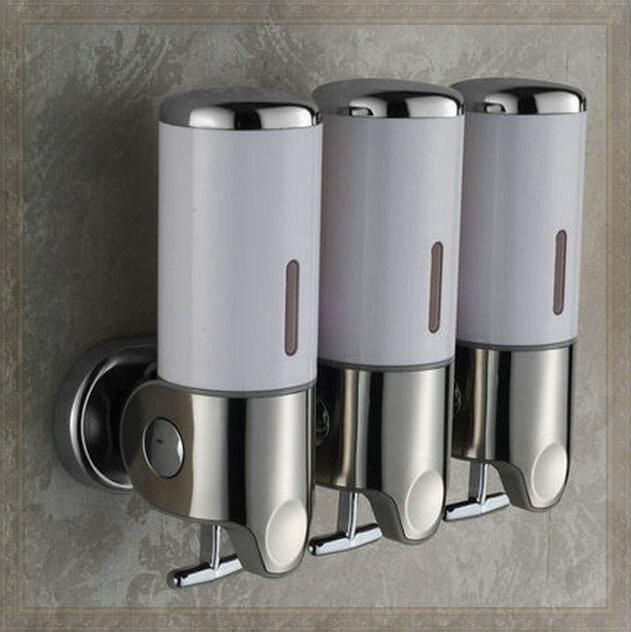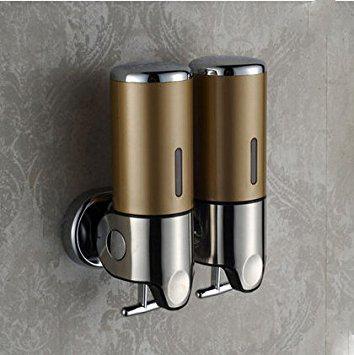The first image is the image on the left, the second image is the image on the right. Examine the images to the left and right. Is the description "One of the dispensers is brown and silver." accurate? Answer yes or no. Yes. The first image is the image on the left, the second image is the image on the right. Analyze the images presented: Is the assertion "The shampoo dispensers in the left image share the same color and design." valid? Answer yes or no. Yes. 